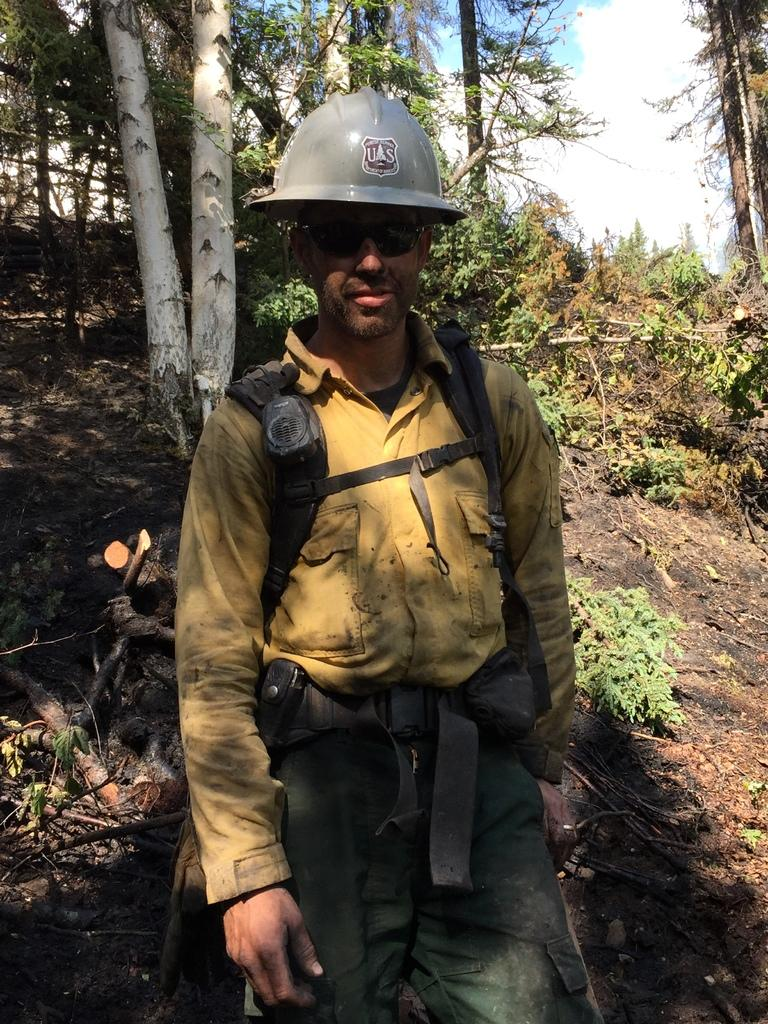Who is present in the image? There is a man in the image. What protective gear is the man wearing? The man is wearing a helmet and goggles. What is the man's position in the image? The man is standing on the ground. What type of vegetation can be seen in the image? There are plants and trees in the image. What is visible in the background of the image? The sky is visible in the background of the image. What can be observed in the sky? Clouds are present in the sky. What grade does the man receive for his comfort in the image? There is no grade given for the man's comfort in the image, as it does not involve any evaluation or assessment of comfort. 